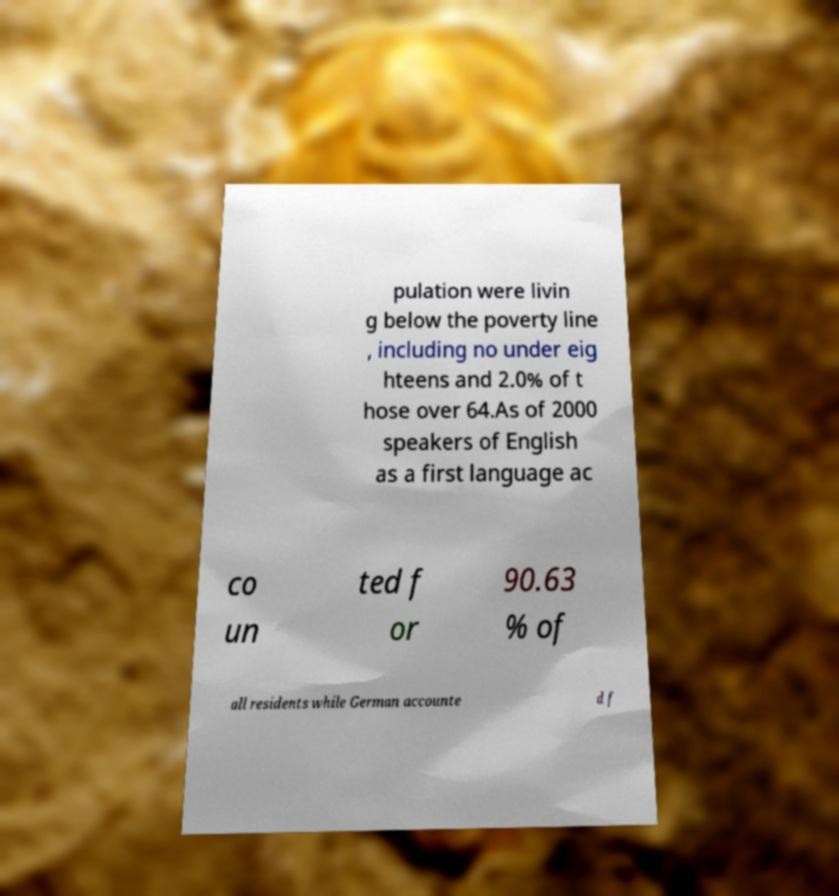Please identify and transcribe the text found in this image. pulation were livin g below the poverty line , including no under eig hteens and 2.0% of t hose over 64.As of 2000 speakers of English as a first language ac co un ted f or 90.63 % of all residents while German accounte d f 